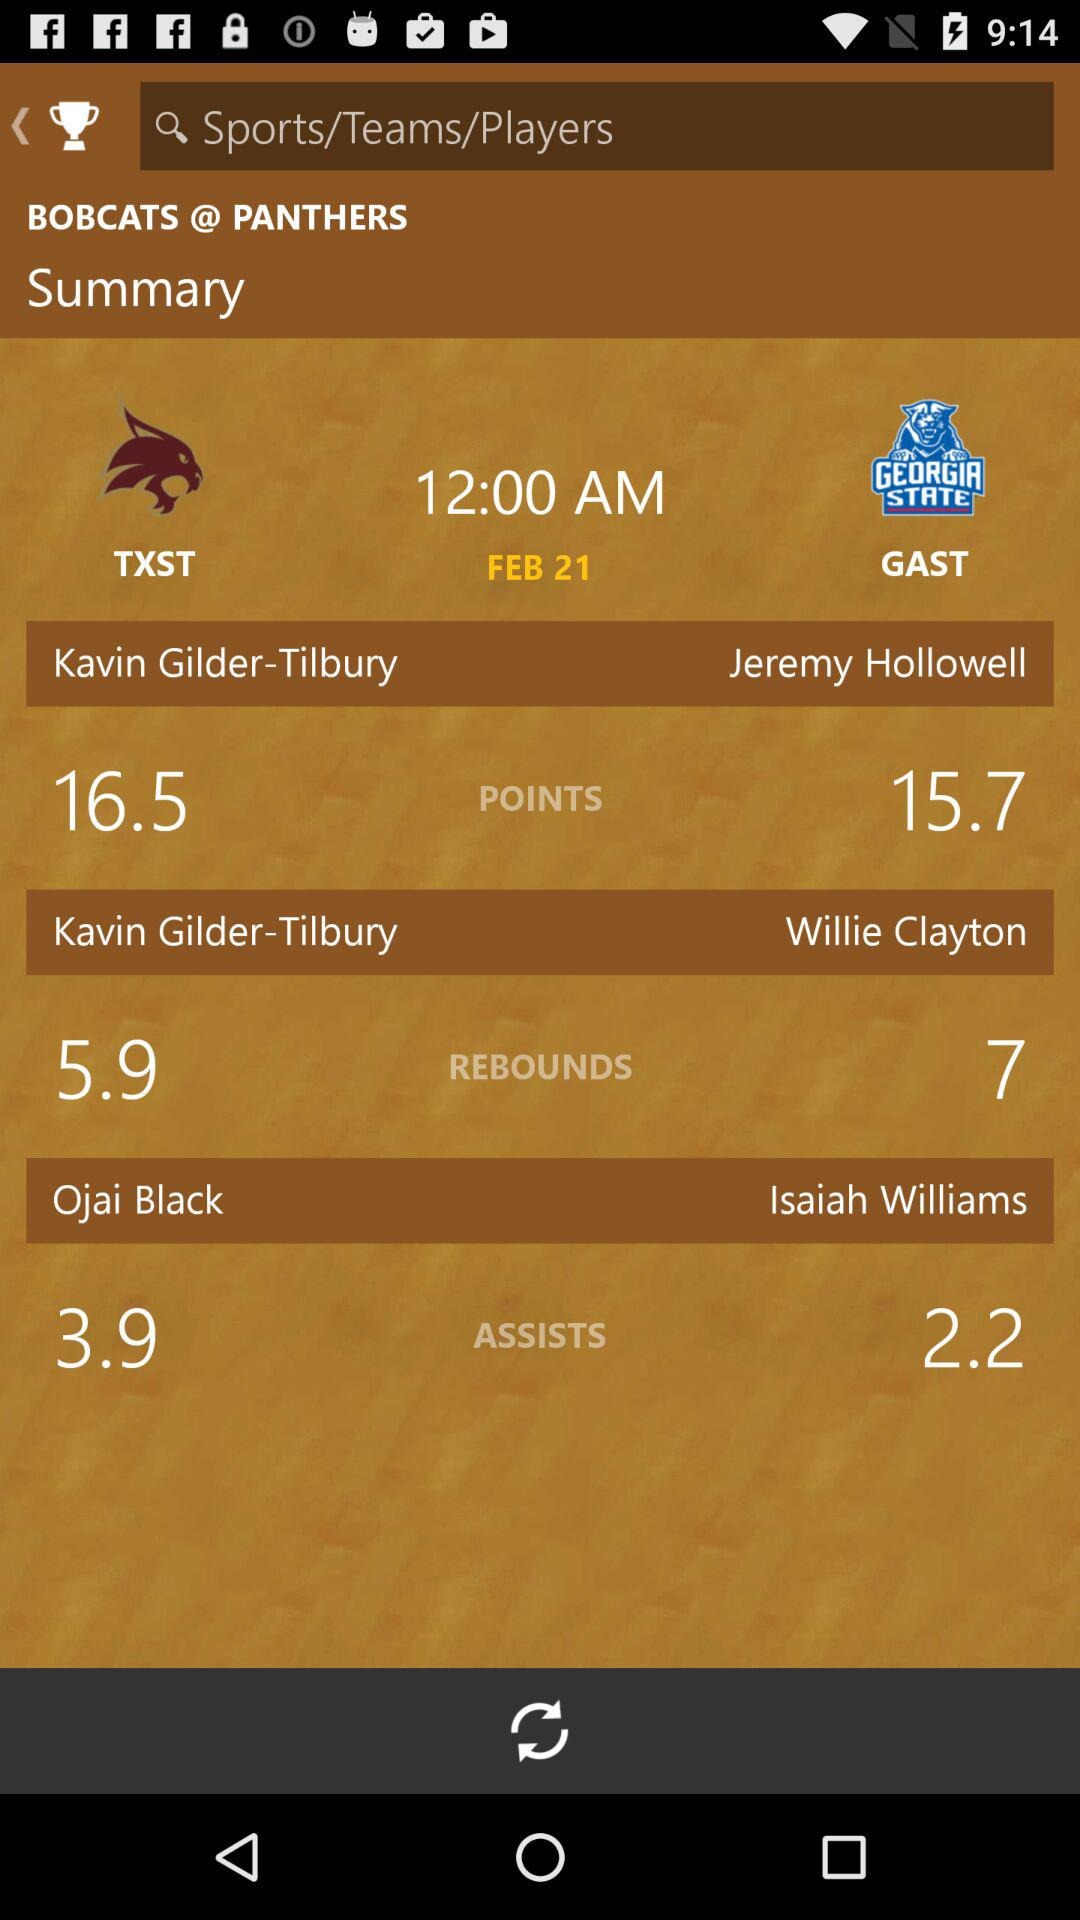Between which teams is the match played? The match is played between "TXST" and "GAST". 